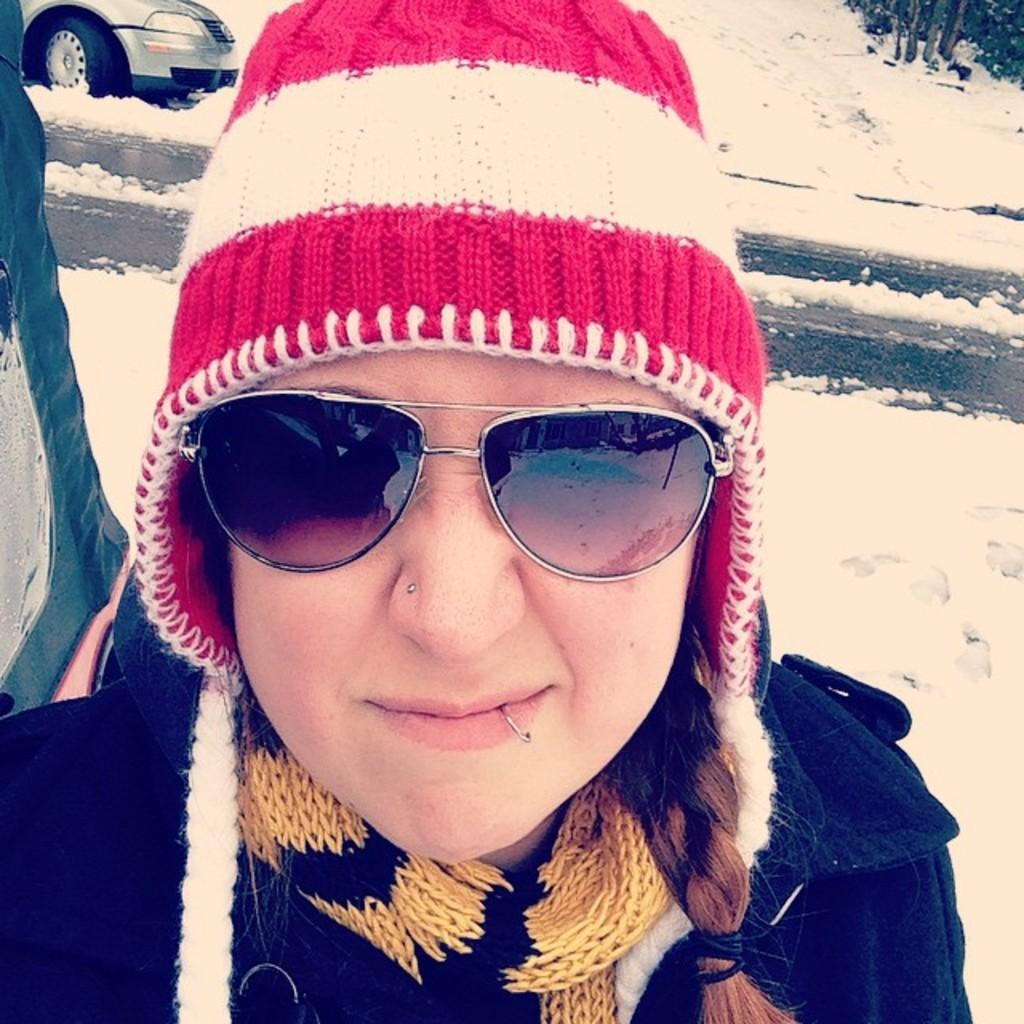What is the person in the image wearing? The person in the image is wearing a dress, cap, and goggles. What can be seen in the background of the image? There is snow, a vehicle, and trees in the background of the image. What type of railway is visible in the image? There is no railway present in the image. 